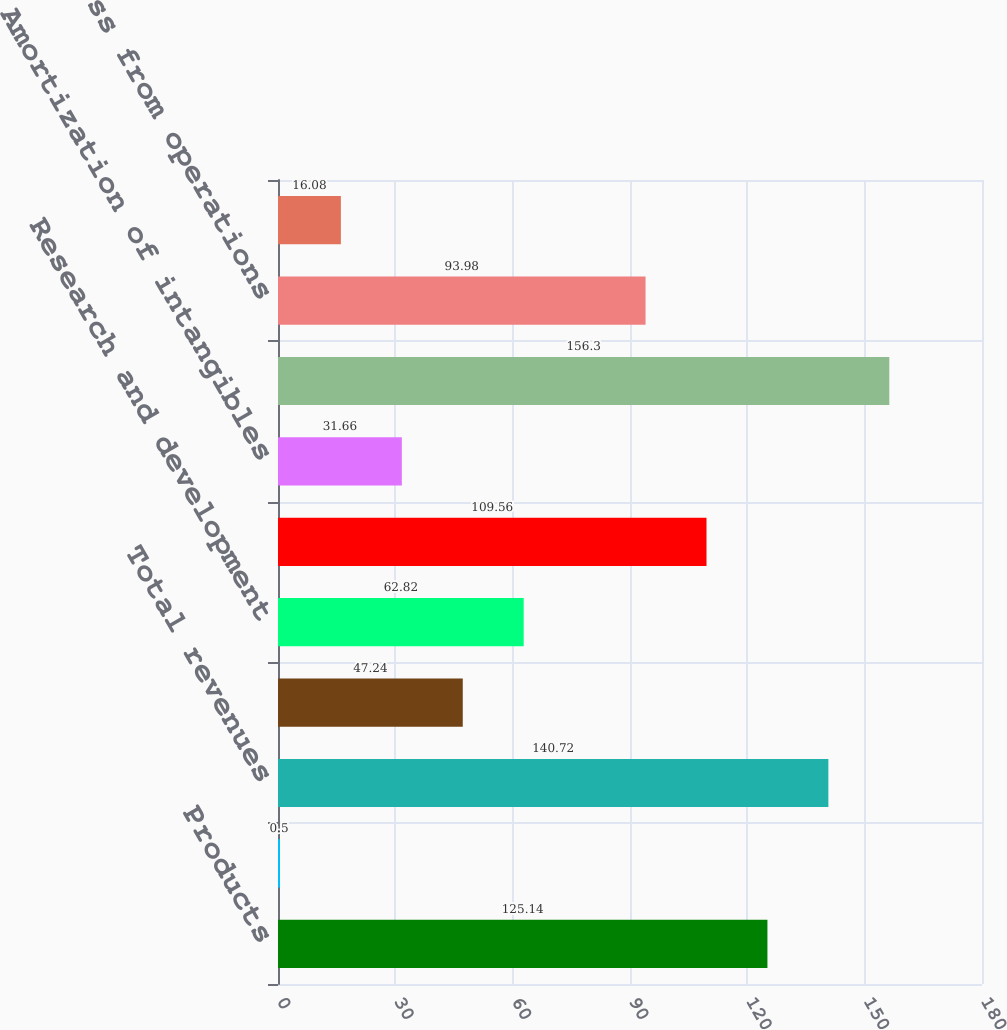Convert chart to OTSL. <chart><loc_0><loc_0><loc_500><loc_500><bar_chart><fcel>Products<fcel>Funded research and<fcel>Total revenues<fcel>Cost of product revenues<fcel>Research and development<fcel>Selling general and<fcel>Amortization of intangibles<fcel>Total costs and expenses<fcel>Loss from operations<fcel>Other income net<nl><fcel>125.14<fcel>0.5<fcel>140.72<fcel>47.24<fcel>62.82<fcel>109.56<fcel>31.66<fcel>156.3<fcel>93.98<fcel>16.08<nl></chart> 